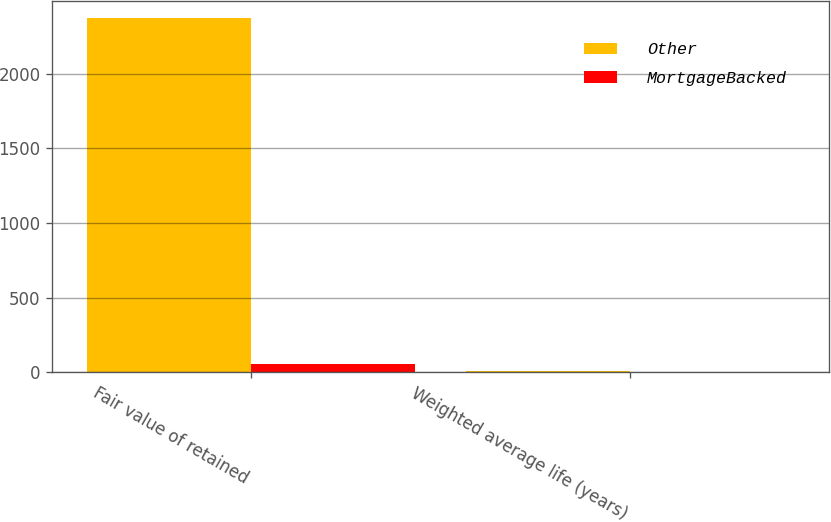Convert chart. <chart><loc_0><loc_0><loc_500><loc_500><stacked_bar_chart><ecel><fcel>Fair value of retained<fcel>Weighted average life (years)<nl><fcel>Other<fcel>2370<fcel>7.6<nl><fcel>MortgageBacked<fcel>59<fcel>3.6<nl></chart> 